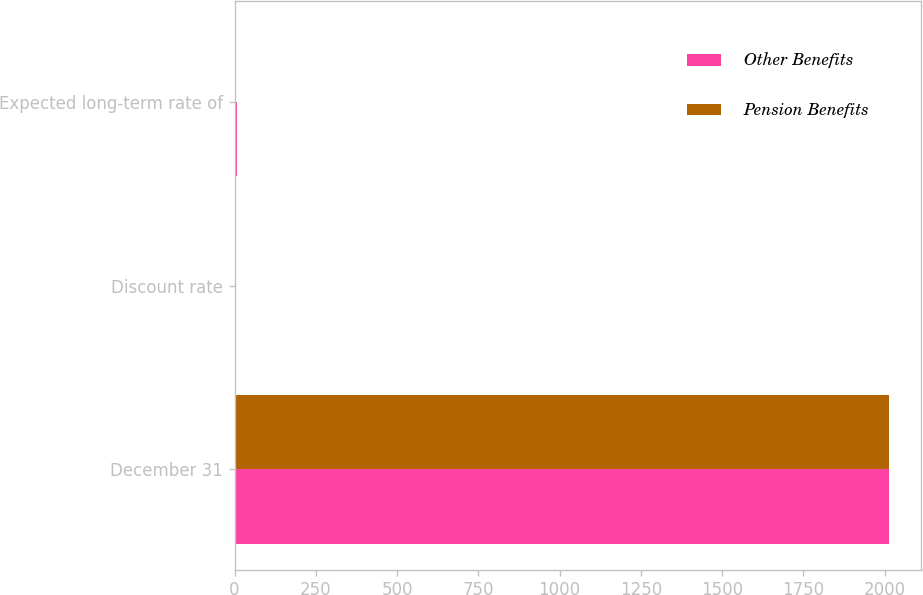Convert chart. <chart><loc_0><loc_0><loc_500><loc_500><stacked_bar_chart><ecel><fcel>December 31<fcel>Discount rate<fcel>Expected long-term rate of<nl><fcel>Other Benefits<fcel>2012<fcel>4.75<fcel>8.25<nl><fcel>Pension Benefits<fcel>2012<fcel>4.75<fcel>4.75<nl></chart> 